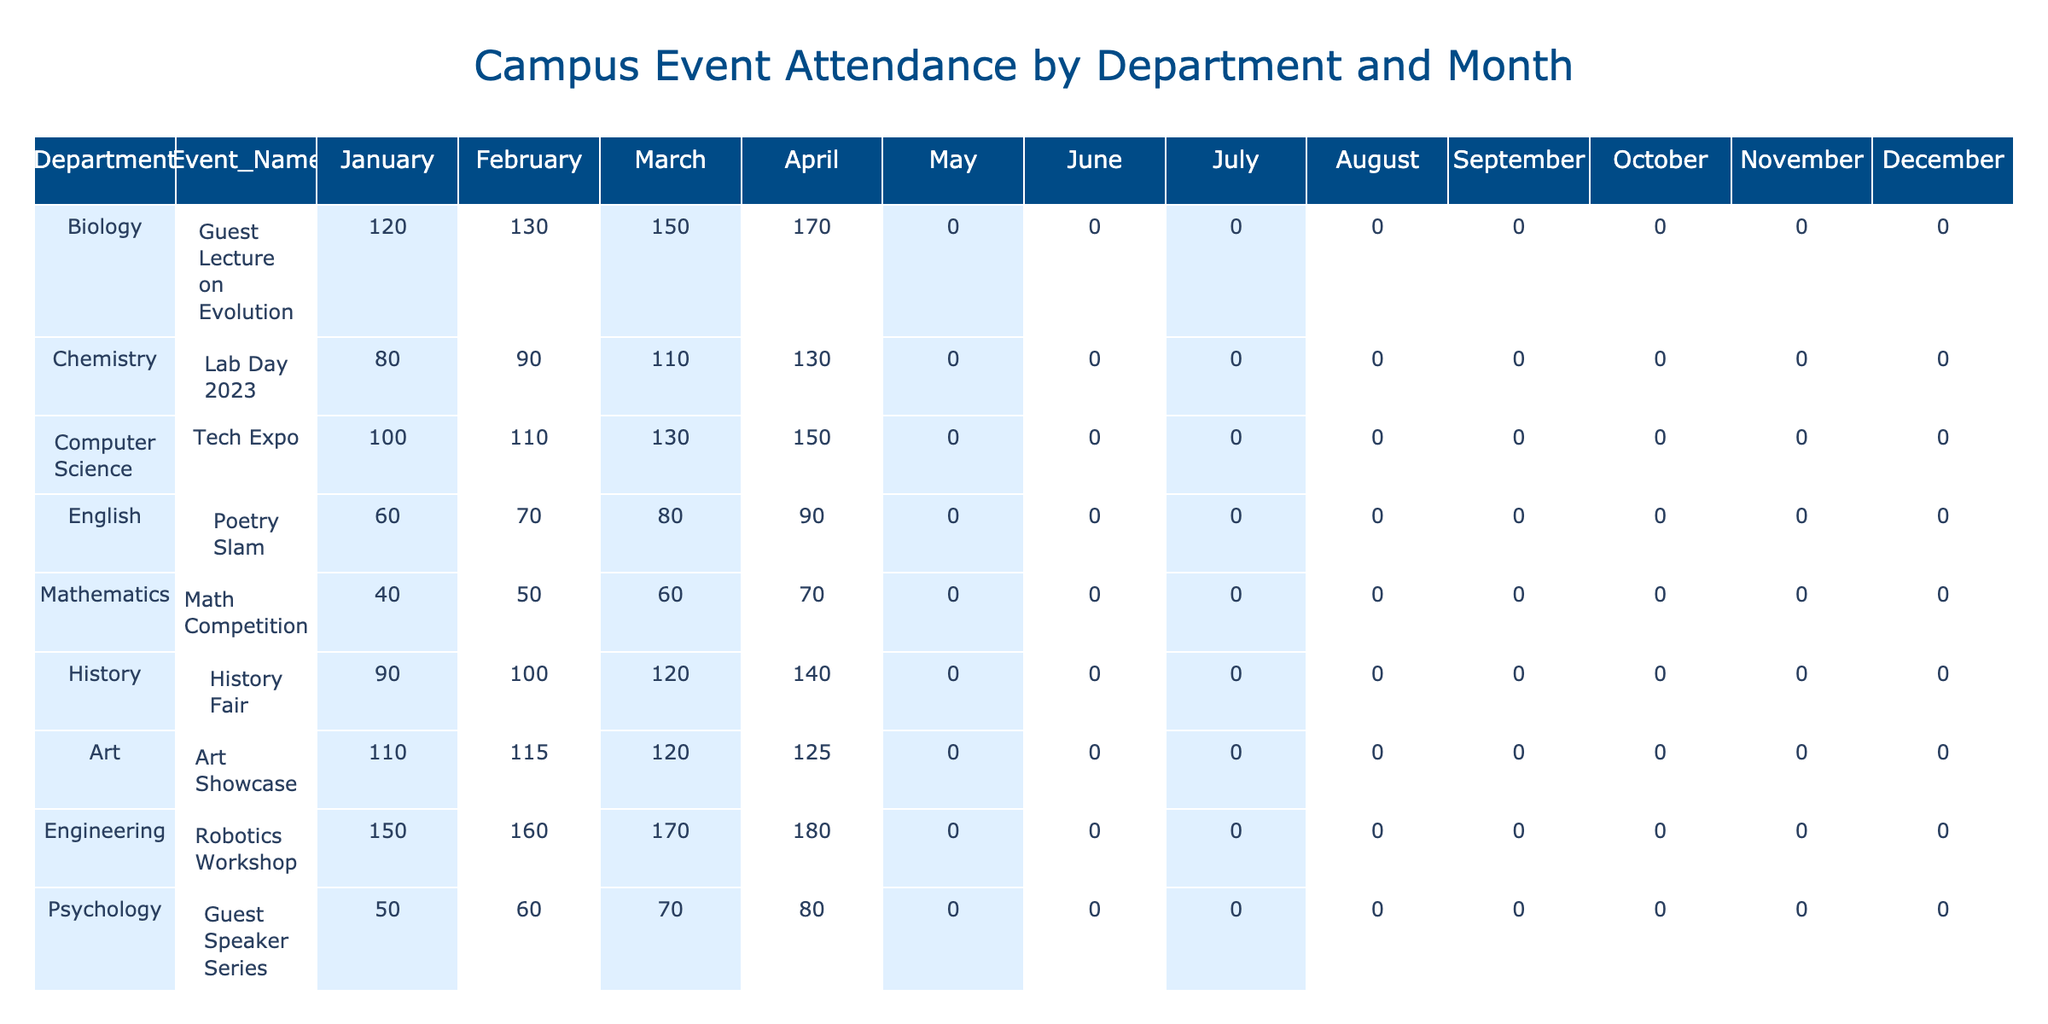What department had the highest attendance in April? By checking the April column for attendance numbers, Engineering has the highest value with 180 attendees.
Answer: Engineering What was the total attendance for Computer Science events over the year? Summing the attendance from all months for Computer Science: (100 + 110 + 130 + 150 + 0 + 0 + 0 + 0 + 0 + 0 + 0 + 0) = 490.
Answer: 490 Did the Art department host any events in May? The attendance for the Art department in May is 0, indicating no event was held.
Answer: No What is the difference in attendance between the History Fair in March and the Poetry Slam in March? History Fair had 120 attendees in March, while Poetry Slam had 80. The difference is 120 - 80 = 40.
Answer: 40 Which month had the lowest overall attendance across all departments? Since all months except January to April have 0 attendance, the months from May to December are the lowest with 0 attendees.
Answer: May to December What was the average attendance for Biology events throughout the year? Adding the monthly attendances: (120 + 130 + 150 + 170 + 0 + 0 + 0 + 0 + 0 + 0 + 0 + 0) = 570, and dividing by 12 months gives an average of 570 / 12 = 47.5.
Answer: 47.5 In which month did the Engineering department show the most attendees? Looking at the Engineering attendance numbers, they peaked in April with 180 attendees.
Answer: April Is the attendance for the Entrepreneurship Panel greater than that for the Guest Lecture on Evolution in February? The Entrepreneurship Panel had 85 attendees, while the Guest Lecture had 130 attendees in February. Since 85 < 130, the statement is false.
Answer: No Which event had the lowest attendance in October? All events had an attendance of 0 in October, making it the lowest attendance.
Answer: 0 What is the total number of attendees for all events in January? Adding the attendance numbers for January: (120 + 80 + 100 + 60 + 40 + 90 + 110 + 150 + 50 + 75) = 825.
Answer: 825 How many departments had attendance numbers greater than 100 in March? In March, the departments with attendance over 100 are Biology (150), Chemistry (110), Computer Science (130), Engineering (170), and History (120), totaling 5 departments.
Answer: 5 